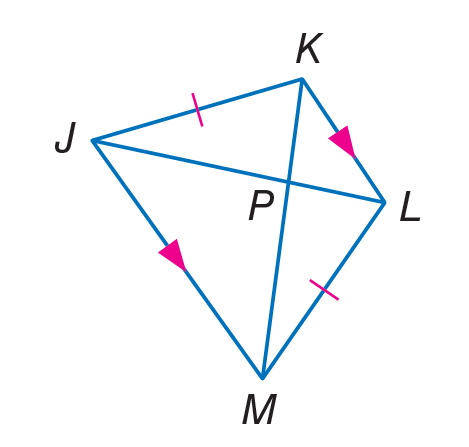Answer the mathemtical geometry problem and directly provide the correct option letter.
Question: Find J L, if K P = 4 and P M = 7.
Choices: A: 3 B: 4 C: 7 D: 11 D 